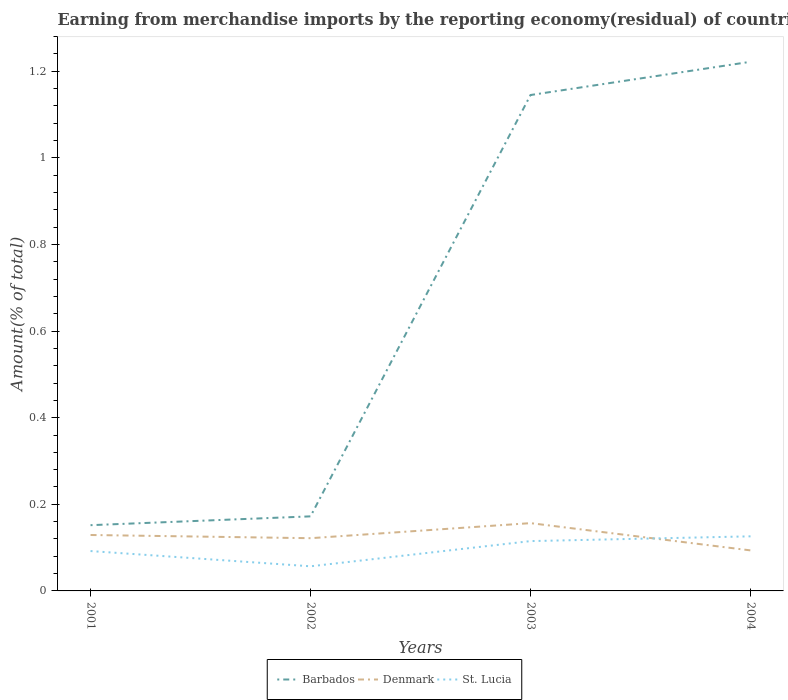How many different coloured lines are there?
Keep it short and to the point. 3. Is the number of lines equal to the number of legend labels?
Your answer should be compact. Yes. Across all years, what is the maximum percentage of amount earned from merchandise imports in St. Lucia?
Offer a terse response. 0.06. What is the total percentage of amount earned from merchandise imports in St. Lucia in the graph?
Keep it short and to the point. -0.01. What is the difference between the highest and the second highest percentage of amount earned from merchandise imports in St. Lucia?
Offer a terse response. 0.07. Is the percentage of amount earned from merchandise imports in St. Lucia strictly greater than the percentage of amount earned from merchandise imports in Denmark over the years?
Make the answer very short. No. What is the difference between two consecutive major ticks on the Y-axis?
Make the answer very short. 0.2. Are the values on the major ticks of Y-axis written in scientific E-notation?
Your answer should be compact. No. Does the graph contain any zero values?
Your response must be concise. No. How are the legend labels stacked?
Offer a very short reply. Horizontal. What is the title of the graph?
Provide a succinct answer. Earning from merchandise imports by the reporting economy(residual) of countries. What is the label or title of the Y-axis?
Ensure brevity in your answer.  Amount(% of total). What is the Amount(% of total) of Barbados in 2001?
Your answer should be very brief. 0.15. What is the Amount(% of total) in Denmark in 2001?
Provide a short and direct response. 0.13. What is the Amount(% of total) in St. Lucia in 2001?
Offer a very short reply. 0.09. What is the Amount(% of total) of Barbados in 2002?
Your answer should be compact. 0.17. What is the Amount(% of total) in Denmark in 2002?
Provide a succinct answer. 0.12. What is the Amount(% of total) of St. Lucia in 2002?
Your answer should be compact. 0.06. What is the Amount(% of total) of Barbados in 2003?
Provide a short and direct response. 1.15. What is the Amount(% of total) in Denmark in 2003?
Provide a succinct answer. 0.16. What is the Amount(% of total) in St. Lucia in 2003?
Your response must be concise. 0.12. What is the Amount(% of total) in Barbados in 2004?
Your response must be concise. 1.22. What is the Amount(% of total) in Denmark in 2004?
Make the answer very short. 0.09. What is the Amount(% of total) of St. Lucia in 2004?
Give a very brief answer. 0.13. Across all years, what is the maximum Amount(% of total) in Barbados?
Your answer should be compact. 1.22. Across all years, what is the maximum Amount(% of total) in Denmark?
Give a very brief answer. 0.16. Across all years, what is the maximum Amount(% of total) of St. Lucia?
Offer a very short reply. 0.13. Across all years, what is the minimum Amount(% of total) of Barbados?
Provide a short and direct response. 0.15. Across all years, what is the minimum Amount(% of total) of Denmark?
Offer a very short reply. 0.09. Across all years, what is the minimum Amount(% of total) of St. Lucia?
Your answer should be compact. 0.06. What is the total Amount(% of total) in Barbados in the graph?
Offer a very short reply. 2.69. What is the total Amount(% of total) of Denmark in the graph?
Provide a short and direct response. 0.5. What is the total Amount(% of total) in St. Lucia in the graph?
Provide a short and direct response. 0.39. What is the difference between the Amount(% of total) in Barbados in 2001 and that in 2002?
Provide a short and direct response. -0.02. What is the difference between the Amount(% of total) in Denmark in 2001 and that in 2002?
Give a very brief answer. 0.01. What is the difference between the Amount(% of total) of St. Lucia in 2001 and that in 2002?
Your answer should be compact. 0.04. What is the difference between the Amount(% of total) of Barbados in 2001 and that in 2003?
Make the answer very short. -0.99. What is the difference between the Amount(% of total) of Denmark in 2001 and that in 2003?
Offer a terse response. -0.03. What is the difference between the Amount(% of total) in St. Lucia in 2001 and that in 2003?
Your answer should be compact. -0.02. What is the difference between the Amount(% of total) of Barbados in 2001 and that in 2004?
Give a very brief answer. -1.07. What is the difference between the Amount(% of total) of Denmark in 2001 and that in 2004?
Keep it short and to the point. 0.04. What is the difference between the Amount(% of total) of St. Lucia in 2001 and that in 2004?
Offer a terse response. -0.03. What is the difference between the Amount(% of total) in Barbados in 2002 and that in 2003?
Provide a short and direct response. -0.97. What is the difference between the Amount(% of total) of Denmark in 2002 and that in 2003?
Offer a terse response. -0.03. What is the difference between the Amount(% of total) of St. Lucia in 2002 and that in 2003?
Your response must be concise. -0.06. What is the difference between the Amount(% of total) of Barbados in 2002 and that in 2004?
Ensure brevity in your answer.  -1.05. What is the difference between the Amount(% of total) of Denmark in 2002 and that in 2004?
Your response must be concise. 0.03. What is the difference between the Amount(% of total) of St. Lucia in 2002 and that in 2004?
Ensure brevity in your answer.  -0.07. What is the difference between the Amount(% of total) of Barbados in 2003 and that in 2004?
Provide a short and direct response. -0.08. What is the difference between the Amount(% of total) of Denmark in 2003 and that in 2004?
Give a very brief answer. 0.06. What is the difference between the Amount(% of total) of St. Lucia in 2003 and that in 2004?
Your answer should be compact. -0.01. What is the difference between the Amount(% of total) of Barbados in 2001 and the Amount(% of total) of Denmark in 2002?
Ensure brevity in your answer.  0.03. What is the difference between the Amount(% of total) of Barbados in 2001 and the Amount(% of total) of St. Lucia in 2002?
Ensure brevity in your answer.  0.1. What is the difference between the Amount(% of total) of Denmark in 2001 and the Amount(% of total) of St. Lucia in 2002?
Your answer should be very brief. 0.07. What is the difference between the Amount(% of total) of Barbados in 2001 and the Amount(% of total) of Denmark in 2003?
Offer a terse response. -0. What is the difference between the Amount(% of total) of Barbados in 2001 and the Amount(% of total) of St. Lucia in 2003?
Keep it short and to the point. 0.04. What is the difference between the Amount(% of total) of Denmark in 2001 and the Amount(% of total) of St. Lucia in 2003?
Keep it short and to the point. 0.01. What is the difference between the Amount(% of total) of Barbados in 2001 and the Amount(% of total) of Denmark in 2004?
Ensure brevity in your answer.  0.06. What is the difference between the Amount(% of total) in Barbados in 2001 and the Amount(% of total) in St. Lucia in 2004?
Provide a succinct answer. 0.03. What is the difference between the Amount(% of total) in Denmark in 2001 and the Amount(% of total) in St. Lucia in 2004?
Provide a short and direct response. 0. What is the difference between the Amount(% of total) in Barbados in 2002 and the Amount(% of total) in Denmark in 2003?
Offer a terse response. 0.02. What is the difference between the Amount(% of total) in Barbados in 2002 and the Amount(% of total) in St. Lucia in 2003?
Offer a terse response. 0.06. What is the difference between the Amount(% of total) of Denmark in 2002 and the Amount(% of total) of St. Lucia in 2003?
Your answer should be very brief. 0.01. What is the difference between the Amount(% of total) of Barbados in 2002 and the Amount(% of total) of Denmark in 2004?
Ensure brevity in your answer.  0.08. What is the difference between the Amount(% of total) in Barbados in 2002 and the Amount(% of total) in St. Lucia in 2004?
Give a very brief answer. 0.05. What is the difference between the Amount(% of total) of Denmark in 2002 and the Amount(% of total) of St. Lucia in 2004?
Provide a succinct answer. -0. What is the difference between the Amount(% of total) in Barbados in 2003 and the Amount(% of total) in Denmark in 2004?
Your response must be concise. 1.05. What is the difference between the Amount(% of total) of Barbados in 2003 and the Amount(% of total) of St. Lucia in 2004?
Ensure brevity in your answer.  1.02. What is the difference between the Amount(% of total) in Denmark in 2003 and the Amount(% of total) in St. Lucia in 2004?
Provide a succinct answer. 0.03. What is the average Amount(% of total) in Barbados per year?
Provide a short and direct response. 0.67. What is the average Amount(% of total) of Denmark per year?
Provide a short and direct response. 0.13. What is the average Amount(% of total) of St. Lucia per year?
Provide a short and direct response. 0.1. In the year 2001, what is the difference between the Amount(% of total) in Barbados and Amount(% of total) in Denmark?
Keep it short and to the point. 0.02. In the year 2001, what is the difference between the Amount(% of total) in Barbados and Amount(% of total) in St. Lucia?
Ensure brevity in your answer.  0.06. In the year 2001, what is the difference between the Amount(% of total) in Denmark and Amount(% of total) in St. Lucia?
Ensure brevity in your answer.  0.04. In the year 2002, what is the difference between the Amount(% of total) in Barbados and Amount(% of total) in Denmark?
Offer a very short reply. 0.05. In the year 2002, what is the difference between the Amount(% of total) of Barbados and Amount(% of total) of St. Lucia?
Offer a very short reply. 0.12. In the year 2002, what is the difference between the Amount(% of total) in Denmark and Amount(% of total) in St. Lucia?
Offer a very short reply. 0.06. In the year 2003, what is the difference between the Amount(% of total) of Barbados and Amount(% of total) of Denmark?
Make the answer very short. 0.99. In the year 2003, what is the difference between the Amount(% of total) in Barbados and Amount(% of total) in St. Lucia?
Provide a short and direct response. 1.03. In the year 2003, what is the difference between the Amount(% of total) in Denmark and Amount(% of total) in St. Lucia?
Ensure brevity in your answer.  0.04. In the year 2004, what is the difference between the Amount(% of total) in Barbados and Amount(% of total) in Denmark?
Offer a very short reply. 1.13. In the year 2004, what is the difference between the Amount(% of total) in Barbados and Amount(% of total) in St. Lucia?
Offer a terse response. 1.1. In the year 2004, what is the difference between the Amount(% of total) in Denmark and Amount(% of total) in St. Lucia?
Offer a terse response. -0.03. What is the ratio of the Amount(% of total) in Barbados in 2001 to that in 2002?
Give a very brief answer. 0.88. What is the ratio of the Amount(% of total) of Denmark in 2001 to that in 2002?
Provide a succinct answer. 1.06. What is the ratio of the Amount(% of total) in St. Lucia in 2001 to that in 2002?
Ensure brevity in your answer.  1.62. What is the ratio of the Amount(% of total) in Barbados in 2001 to that in 2003?
Offer a terse response. 0.13. What is the ratio of the Amount(% of total) in Denmark in 2001 to that in 2003?
Offer a terse response. 0.83. What is the ratio of the Amount(% of total) of St. Lucia in 2001 to that in 2003?
Your response must be concise. 0.8. What is the ratio of the Amount(% of total) of Barbados in 2001 to that in 2004?
Make the answer very short. 0.12. What is the ratio of the Amount(% of total) in Denmark in 2001 to that in 2004?
Give a very brief answer. 1.38. What is the ratio of the Amount(% of total) of St. Lucia in 2001 to that in 2004?
Make the answer very short. 0.73. What is the ratio of the Amount(% of total) in Barbados in 2002 to that in 2003?
Your answer should be compact. 0.15. What is the ratio of the Amount(% of total) in Denmark in 2002 to that in 2003?
Provide a short and direct response. 0.78. What is the ratio of the Amount(% of total) in St. Lucia in 2002 to that in 2003?
Make the answer very short. 0.49. What is the ratio of the Amount(% of total) of Barbados in 2002 to that in 2004?
Offer a terse response. 0.14. What is the ratio of the Amount(% of total) in Denmark in 2002 to that in 2004?
Provide a short and direct response. 1.3. What is the ratio of the Amount(% of total) in St. Lucia in 2002 to that in 2004?
Ensure brevity in your answer.  0.45. What is the ratio of the Amount(% of total) of Barbados in 2003 to that in 2004?
Give a very brief answer. 0.94. What is the ratio of the Amount(% of total) in Denmark in 2003 to that in 2004?
Your answer should be very brief. 1.67. What is the ratio of the Amount(% of total) of St. Lucia in 2003 to that in 2004?
Keep it short and to the point. 0.91. What is the difference between the highest and the second highest Amount(% of total) in Barbados?
Offer a terse response. 0.08. What is the difference between the highest and the second highest Amount(% of total) in Denmark?
Offer a very short reply. 0.03. What is the difference between the highest and the second highest Amount(% of total) of St. Lucia?
Ensure brevity in your answer.  0.01. What is the difference between the highest and the lowest Amount(% of total) of Barbados?
Your response must be concise. 1.07. What is the difference between the highest and the lowest Amount(% of total) of Denmark?
Offer a very short reply. 0.06. What is the difference between the highest and the lowest Amount(% of total) in St. Lucia?
Make the answer very short. 0.07. 